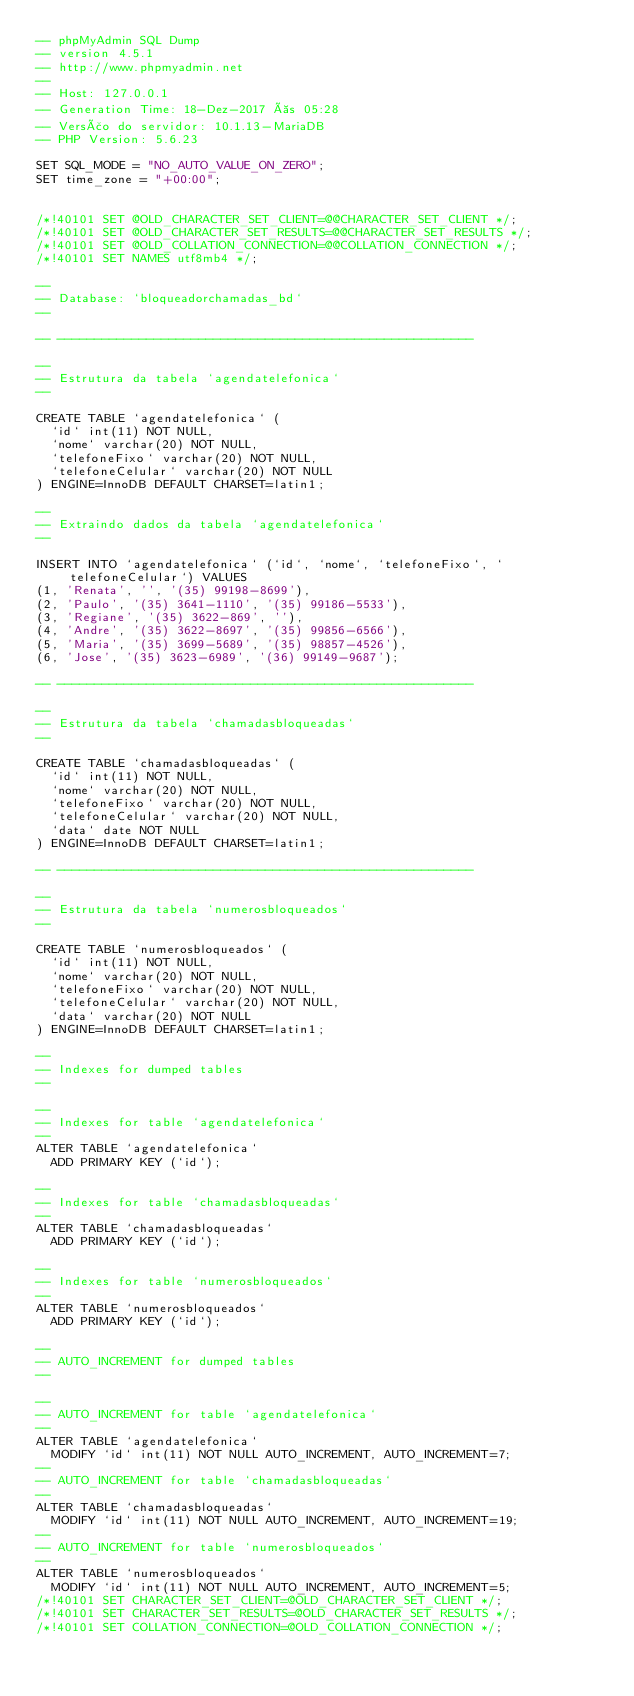<code> <loc_0><loc_0><loc_500><loc_500><_SQL_>-- phpMyAdmin SQL Dump
-- version 4.5.1
-- http://www.phpmyadmin.net
--
-- Host: 127.0.0.1
-- Generation Time: 18-Dez-2017 às 05:28
-- Versão do servidor: 10.1.13-MariaDB
-- PHP Version: 5.6.23

SET SQL_MODE = "NO_AUTO_VALUE_ON_ZERO";
SET time_zone = "+00:00";


/*!40101 SET @OLD_CHARACTER_SET_CLIENT=@@CHARACTER_SET_CLIENT */;
/*!40101 SET @OLD_CHARACTER_SET_RESULTS=@@CHARACTER_SET_RESULTS */;
/*!40101 SET @OLD_COLLATION_CONNECTION=@@COLLATION_CONNECTION */;
/*!40101 SET NAMES utf8mb4 */;

--
-- Database: `bloqueadorchamadas_bd`
--

-- --------------------------------------------------------

--
-- Estrutura da tabela `agendatelefonica`
--

CREATE TABLE `agendatelefonica` (
  `id` int(11) NOT NULL,
  `nome` varchar(20) NOT NULL,
  `telefoneFixo` varchar(20) NOT NULL,
  `telefoneCelular` varchar(20) NOT NULL
) ENGINE=InnoDB DEFAULT CHARSET=latin1;

--
-- Extraindo dados da tabela `agendatelefonica`
--

INSERT INTO `agendatelefonica` (`id`, `nome`, `telefoneFixo`, `telefoneCelular`) VALUES
(1, 'Renata', '', '(35) 99198-8699'),
(2, 'Paulo', '(35) 3641-1110', '(35) 99186-5533'),
(3, 'Regiane', '(35) 3622-869', ''),
(4, 'Andre', '(35) 3622-8697', '(35) 99856-6566'),
(5, 'Maria', '(35) 3699-5689', '(35) 98857-4526'),
(6, 'Jose', '(35) 3623-6989', '(36) 99149-9687');

-- --------------------------------------------------------

--
-- Estrutura da tabela `chamadasbloqueadas`
--

CREATE TABLE `chamadasbloqueadas` (
  `id` int(11) NOT NULL,
  `nome` varchar(20) NOT NULL,
  `telefoneFixo` varchar(20) NOT NULL,
  `telefoneCelular` varchar(20) NOT NULL,
  `data` date NOT NULL
) ENGINE=InnoDB DEFAULT CHARSET=latin1;

-- --------------------------------------------------------

--
-- Estrutura da tabela `numerosbloqueados`
--

CREATE TABLE `numerosbloqueados` (
  `id` int(11) NOT NULL,
  `nome` varchar(20) NOT NULL,
  `telefoneFixo` varchar(20) NOT NULL,
  `telefoneCelular` varchar(20) NOT NULL,
  `data` varchar(20) NOT NULL
) ENGINE=InnoDB DEFAULT CHARSET=latin1;

--
-- Indexes for dumped tables
--

--
-- Indexes for table `agendatelefonica`
--
ALTER TABLE `agendatelefonica`
  ADD PRIMARY KEY (`id`);

--
-- Indexes for table `chamadasbloqueadas`
--
ALTER TABLE `chamadasbloqueadas`
  ADD PRIMARY KEY (`id`);

--
-- Indexes for table `numerosbloqueados`
--
ALTER TABLE `numerosbloqueados`
  ADD PRIMARY KEY (`id`);

--
-- AUTO_INCREMENT for dumped tables
--

--
-- AUTO_INCREMENT for table `agendatelefonica`
--
ALTER TABLE `agendatelefonica`
  MODIFY `id` int(11) NOT NULL AUTO_INCREMENT, AUTO_INCREMENT=7;
--
-- AUTO_INCREMENT for table `chamadasbloqueadas`
--
ALTER TABLE `chamadasbloqueadas`
  MODIFY `id` int(11) NOT NULL AUTO_INCREMENT, AUTO_INCREMENT=19;
--
-- AUTO_INCREMENT for table `numerosbloqueados`
--
ALTER TABLE `numerosbloqueados`
  MODIFY `id` int(11) NOT NULL AUTO_INCREMENT, AUTO_INCREMENT=5;
/*!40101 SET CHARACTER_SET_CLIENT=@OLD_CHARACTER_SET_CLIENT */;
/*!40101 SET CHARACTER_SET_RESULTS=@OLD_CHARACTER_SET_RESULTS */;
/*!40101 SET COLLATION_CONNECTION=@OLD_COLLATION_CONNECTION */;
</code> 